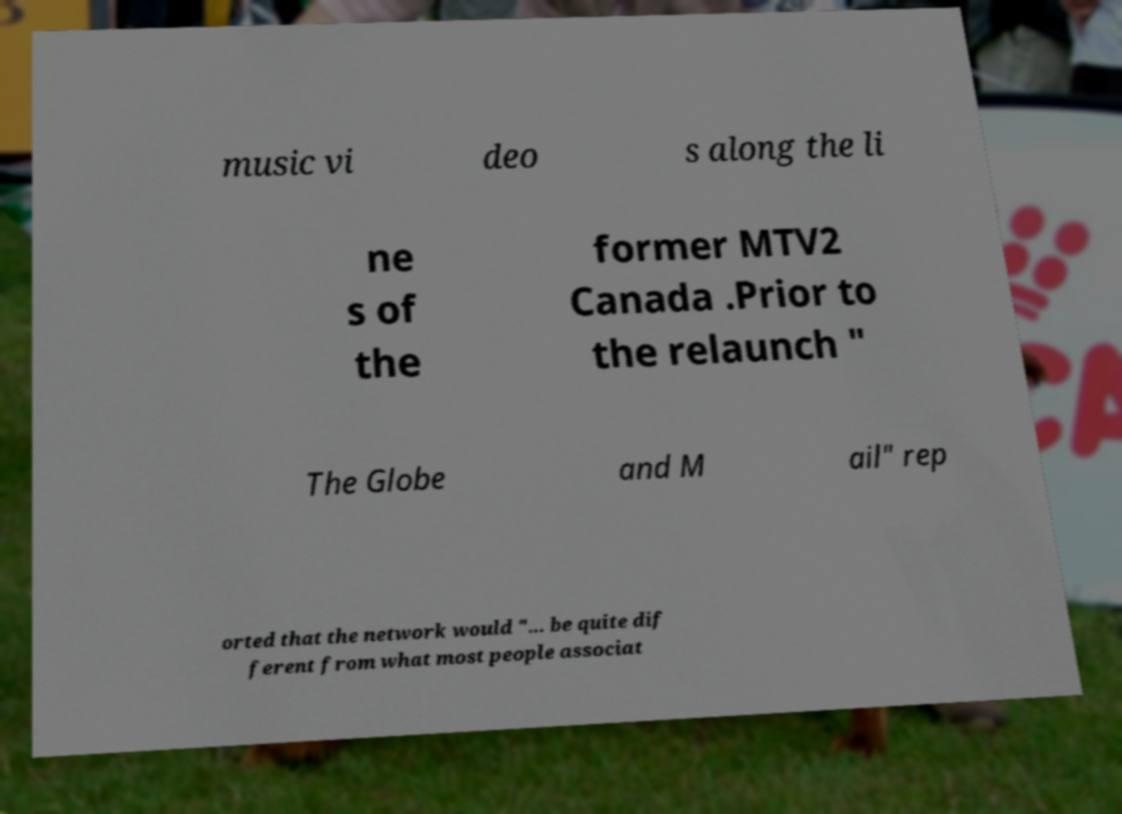What messages or text are displayed in this image? I need them in a readable, typed format. music vi deo s along the li ne s of the former MTV2 Canada .Prior to the relaunch " The Globe and M ail" rep orted that the network would "... be quite dif ferent from what most people associat 